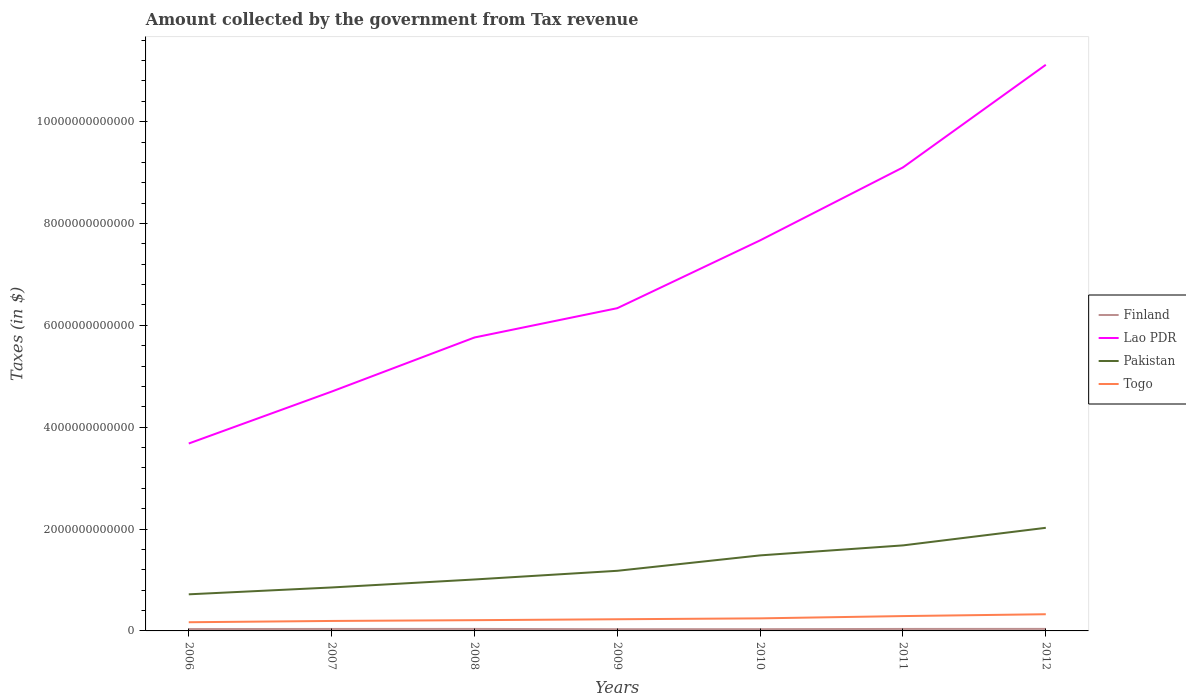Is the number of lines equal to the number of legend labels?
Your answer should be compact. Yes. Across all years, what is the maximum amount collected by the government from tax revenue in Finland?
Provide a short and direct response. 3.38e+1. In which year was the amount collected by the government from tax revenue in Pakistan maximum?
Give a very brief answer. 2006. What is the total amount collected by the government from tax revenue in Finland in the graph?
Ensure brevity in your answer.  -5.21e+09. What is the difference between the highest and the second highest amount collected by the government from tax revenue in Togo?
Offer a terse response. 1.57e+11. What is the difference between the highest and the lowest amount collected by the government from tax revenue in Finland?
Your answer should be very brief. 4. What is the difference between two consecutive major ticks on the Y-axis?
Your answer should be compact. 2.00e+12. Does the graph contain any zero values?
Provide a short and direct response. No. Does the graph contain grids?
Your response must be concise. No. How many legend labels are there?
Offer a terse response. 4. How are the legend labels stacked?
Your answer should be very brief. Vertical. What is the title of the graph?
Offer a terse response. Amount collected by the government from Tax revenue. Does "Ireland" appear as one of the legend labels in the graph?
Your answer should be compact. No. What is the label or title of the X-axis?
Provide a short and direct response. Years. What is the label or title of the Y-axis?
Your answer should be compact. Taxes (in $). What is the Taxes (in $) of Finland in 2006?
Provide a succinct answer. 3.66e+1. What is the Taxes (in $) of Lao PDR in 2006?
Give a very brief answer. 3.68e+12. What is the Taxes (in $) of Pakistan in 2006?
Provide a short and direct response. 7.19e+11. What is the Taxes (in $) in Togo in 2006?
Give a very brief answer. 1.71e+11. What is the Taxes (in $) in Finland in 2007?
Keep it short and to the point. 3.90e+1. What is the Taxes (in $) in Lao PDR in 2007?
Your response must be concise. 4.70e+12. What is the Taxes (in $) of Pakistan in 2007?
Offer a very short reply. 8.53e+11. What is the Taxes (in $) in Togo in 2007?
Keep it short and to the point. 1.96e+11. What is the Taxes (in $) in Finland in 2008?
Provide a short and direct response. 3.94e+1. What is the Taxes (in $) in Lao PDR in 2008?
Ensure brevity in your answer.  5.76e+12. What is the Taxes (in $) in Pakistan in 2008?
Your answer should be very brief. 1.01e+12. What is the Taxes (in $) in Togo in 2008?
Provide a short and direct response. 2.11e+11. What is the Taxes (in $) in Finland in 2009?
Your answer should be very brief. 3.38e+1. What is the Taxes (in $) of Lao PDR in 2009?
Provide a succinct answer. 6.34e+12. What is the Taxes (in $) in Pakistan in 2009?
Give a very brief answer. 1.18e+12. What is the Taxes (in $) in Togo in 2009?
Provide a short and direct response. 2.29e+11. What is the Taxes (in $) in Finland in 2010?
Offer a very short reply. 3.44e+1. What is the Taxes (in $) of Lao PDR in 2010?
Your answer should be very brief. 7.67e+12. What is the Taxes (in $) in Pakistan in 2010?
Your answer should be very brief. 1.48e+12. What is the Taxes (in $) in Togo in 2010?
Keep it short and to the point. 2.47e+11. What is the Taxes (in $) in Finland in 2011?
Offer a terse response. 3.90e+1. What is the Taxes (in $) in Lao PDR in 2011?
Your answer should be very brief. 9.10e+12. What is the Taxes (in $) of Pakistan in 2011?
Offer a terse response. 1.68e+12. What is the Taxes (in $) in Togo in 2011?
Provide a succinct answer. 2.91e+11. What is the Taxes (in $) of Finland in 2012?
Provide a succinct answer. 3.98e+1. What is the Taxes (in $) of Lao PDR in 2012?
Your answer should be very brief. 1.11e+13. What is the Taxes (in $) in Pakistan in 2012?
Provide a succinct answer. 2.02e+12. What is the Taxes (in $) in Togo in 2012?
Your response must be concise. 3.28e+11. Across all years, what is the maximum Taxes (in $) in Finland?
Your response must be concise. 3.98e+1. Across all years, what is the maximum Taxes (in $) of Lao PDR?
Offer a very short reply. 1.11e+13. Across all years, what is the maximum Taxes (in $) in Pakistan?
Give a very brief answer. 2.02e+12. Across all years, what is the maximum Taxes (in $) in Togo?
Your answer should be compact. 3.28e+11. Across all years, what is the minimum Taxes (in $) in Finland?
Provide a succinct answer. 3.38e+1. Across all years, what is the minimum Taxes (in $) in Lao PDR?
Your answer should be very brief. 3.68e+12. Across all years, what is the minimum Taxes (in $) of Pakistan?
Your answer should be very brief. 7.19e+11. Across all years, what is the minimum Taxes (in $) in Togo?
Keep it short and to the point. 1.71e+11. What is the total Taxes (in $) of Finland in the graph?
Provide a short and direct response. 2.62e+11. What is the total Taxes (in $) in Lao PDR in the graph?
Keep it short and to the point. 4.84e+13. What is the total Taxes (in $) in Pakistan in the graph?
Your answer should be very brief. 8.95e+12. What is the total Taxes (in $) of Togo in the graph?
Give a very brief answer. 1.67e+12. What is the difference between the Taxes (in $) of Finland in 2006 and that in 2007?
Offer a very short reply. -2.32e+09. What is the difference between the Taxes (in $) of Lao PDR in 2006 and that in 2007?
Make the answer very short. -1.02e+12. What is the difference between the Taxes (in $) in Pakistan in 2006 and that in 2007?
Your response must be concise. -1.35e+11. What is the difference between the Taxes (in $) in Togo in 2006 and that in 2007?
Give a very brief answer. -2.53e+1. What is the difference between the Taxes (in $) in Finland in 2006 and that in 2008?
Your answer should be compact. -2.74e+09. What is the difference between the Taxes (in $) in Lao PDR in 2006 and that in 2008?
Make the answer very short. -2.08e+12. What is the difference between the Taxes (in $) of Pakistan in 2006 and that in 2008?
Your response must be concise. -2.91e+11. What is the difference between the Taxes (in $) in Togo in 2006 and that in 2008?
Offer a very short reply. -4.06e+1. What is the difference between the Taxes (in $) of Finland in 2006 and that in 2009?
Offer a terse response. 2.81e+09. What is the difference between the Taxes (in $) in Lao PDR in 2006 and that in 2009?
Your answer should be compact. -2.66e+12. What is the difference between the Taxes (in $) of Pakistan in 2006 and that in 2009?
Offer a terse response. -4.62e+11. What is the difference between the Taxes (in $) of Togo in 2006 and that in 2009?
Offer a very short reply. -5.85e+1. What is the difference between the Taxes (in $) in Finland in 2006 and that in 2010?
Provide a succinct answer. 2.19e+09. What is the difference between the Taxes (in $) of Lao PDR in 2006 and that in 2010?
Your response must be concise. -3.99e+12. What is the difference between the Taxes (in $) of Pakistan in 2006 and that in 2010?
Offer a very short reply. -7.64e+11. What is the difference between the Taxes (in $) in Togo in 2006 and that in 2010?
Keep it short and to the point. -7.62e+1. What is the difference between the Taxes (in $) in Finland in 2006 and that in 2011?
Provide a short and direct response. -2.40e+09. What is the difference between the Taxes (in $) of Lao PDR in 2006 and that in 2011?
Your response must be concise. -5.42e+12. What is the difference between the Taxes (in $) in Pakistan in 2006 and that in 2011?
Make the answer very short. -9.61e+11. What is the difference between the Taxes (in $) of Togo in 2006 and that in 2011?
Make the answer very short. -1.21e+11. What is the difference between the Taxes (in $) in Finland in 2006 and that in 2012?
Provide a short and direct response. -3.18e+09. What is the difference between the Taxes (in $) in Lao PDR in 2006 and that in 2012?
Offer a very short reply. -7.44e+12. What is the difference between the Taxes (in $) in Pakistan in 2006 and that in 2012?
Make the answer very short. -1.31e+12. What is the difference between the Taxes (in $) of Togo in 2006 and that in 2012?
Ensure brevity in your answer.  -1.57e+11. What is the difference between the Taxes (in $) of Finland in 2007 and that in 2008?
Your answer should be very brief. -4.18e+08. What is the difference between the Taxes (in $) in Lao PDR in 2007 and that in 2008?
Give a very brief answer. -1.06e+12. What is the difference between the Taxes (in $) in Pakistan in 2007 and that in 2008?
Keep it short and to the point. -1.57e+11. What is the difference between the Taxes (in $) of Togo in 2007 and that in 2008?
Offer a very short reply. -1.53e+1. What is the difference between the Taxes (in $) in Finland in 2007 and that in 2009?
Provide a succinct answer. 5.14e+09. What is the difference between the Taxes (in $) in Lao PDR in 2007 and that in 2009?
Your response must be concise. -1.64e+12. What is the difference between the Taxes (in $) of Pakistan in 2007 and that in 2009?
Ensure brevity in your answer.  -3.27e+11. What is the difference between the Taxes (in $) in Togo in 2007 and that in 2009?
Offer a terse response. -3.32e+1. What is the difference between the Taxes (in $) of Finland in 2007 and that in 2010?
Provide a short and direct response. 4.51e+09. What is the difference between the Taxes (in $) in Lao PDR in 2007 and that in 2010?
Offer a terse response. -2.97e+12. What is the difference between the Taxes (in $) in Pakistan in 2007 and that in 2010?
Ensure brevity in your answer.  -6.30e+11. What is the difference between the Taxes (in $) of Togo in 2007 and that in 2010?
Ensure brevity in your answer.  -5.09e+1. What is the difference between the Taxes (in $) in Finland in 2007 and that in 2011?
Give a very brief answer. -7.90e+07. What is the difference between the Taxes (in $) in Lao PDR in 2007 and that in 2011?
Keep it short and to the point. -4.40e+12. What is the difference between the Taxes (in $) of Pakistan in 2007 and that in 2011?
Give a very brief answer. -8.26e+11. What is the difference between the Taxes (in $) in Togo in 2007 and that in 2011?
Your answer should be very brief. -9.56e+1. What is the difference between the Taxes (in $) in Finland in 2007 and that in 2012?
Offer a terse response. -8.57e+08. What is the difference between the Taxes (in $) in Lao PDR in 2007 and that in 2012?
Provide a succinct answer. -6.42e+12. What is the difference between the Taxes (in $) in Pakistan in 2007 and that in 2012?
Give a very brief answer. -1.17e+12. What is the difference between the Taxes (in $) of Togo in 2007 and that in 2012?
Provide a succinct answer. -1.32e+11. What is the difference between the Taxes (in $) in Finland in 2008 and that in 2009?
Give a very brief answer. 5.55e+09. What is the difference between the Taxes (in $) in Lao PDR in 2008 and that in 2009?
Ensure brevity in your answer.  -5.76e+11. What is the difference between the Taxes (in $) in Pakistan in 2008 and that in 2009?
Your answer should be very brief. -1.71e+11. What is the difference between the Taxes (in $) of Togo in 2008 and that in 2009?
Your answer should be very brief. -1.79e+1. What is the difference between the Taxes (in $) of Finland in 2008 and that in 2010?
Make the answer very short. 4.93e+09. What is the difference between the Taxes (in $) in Lao PDR in 2008 and that in 2010?
Ensure brevity in your answer.  -1.91e+12. What is the difference between the Taxes (in $) of Pakistan in 2008 and that in 2010?
Ensure brevity in your answer.  -4.73e+11. What is the difference between the Taxes (in $) in Togo in 2008 and that in 2010?
Offer a terse response. -3.56e+1. What is the difference between the Taxes (in $) of Finland in 2008 and that in 2011?
Ensure brevity in your answer.  3.39e+08. What is the difference between the Taxes (in $) of Lao PDR in 2008 and that in 2011?
Provide a short and direct response. -3.34e+12. What is the difference between the Taxes (in $) of Pakistan in 2008 and that in 2011?
Offer a very short reply. -6.69e+11. What is the difference between the Taxes (in $) of Togo in 2008 and that in 2011?
Make the answer very short. -8.02e+1. What is the difference between the Taxes (in $) of Finland in 2008 and that in 2012?
Offer a very short reply. -4.39e+08. What is the difference between the Taxes (in $) in Lao PDR in 2008 and that in 2012?
Provide a succinct answer. -5.35e+12. What is the difference between the Taxes (in $) in Pakistan in 2008 and that in 2012?
Your answer should be compact. -1.01e+12. What is the difference between the Taxes (in $) of Togo in 2008 and that in 2012?
Offer a terse response. -1.16e+11. What is the difference between the Taxes (in $) in Finland in 2009 and that in 2010?
Ensure brevity in your answer.  -6.23e+08. What is the difference between the Taxes (in $) of Lao PDR in 2009 and that in 2010?
Give a very brief answer. -1.33e+12. What is the difference between the Taxes (in $) in Pakistan in 2009 and that in 2010?
Give a very brief answer. -3.03e+11. What is the difference between the Taxes (in $) in Togo in 2009 and that in 2010?
Offer a terse response. -1.77e+1. What is the difference between the Taxes (in $) of Finland in 2009 and that in 2011?
Your response must be concise. -5.21e+09. What is the difference between the Taxes (in $) in Lao PDR in 2009 and that in 2011?
Provide a short and direct response. -2.76e+12. What is the difference between the Taxes (in $) in Pakistan in 2009 and that in 2011?
Give a very brief answer. -4.99e+11. What is the difference between the Taxes (in $) in Togo in 2009 and that in 2011?
Keep it short and to the point. -6.24e+1. What is the difference between the Taxes (in $) of Finland in 2009 and that in 2012?
Provide a succinct answer. -5.99e+09. What is the difference between the Taxes (in $) of Lao PDR in 2009 and that in 2012?
Offer a very short reply. -4.78e+12. What is the difference between the Taxes (in $) in Pakistan in 2009 and that in 2012?
Offer a terse response. -8.44e+11. What is the difference between the Taxes (in $) in Togo in 2009 and that in 2012?
Offer a very short reply. -9.86e+1. What is the difference between the Taxes (in $) in Finland in 2010 and that in 2011?
Offer a terse response. -4.59e+09. What is the difference between the Taxes (in $) of Lao PDR in 2010 and that in 2011?
Give a very brief answer. -1.43e+12. What is the difference between the Taxes (in $) of Pakistan in 2010 and that in 2011?
Your answer should be compact. -1.96e+11. What is the difference between the Taxes (in $) in Togo in 2010 and that in 2011?
Give a very brief answer. -4.47e+1. What is the difference between the Taxes (in $) of Finland in 2010 and that in 2012?
Provide a short and direct response. -5.37e+09. What is the difference between the Taxes (in $) in Lao PDR in 2010 and that in 2012?
Keep it short and to the point. -3.45e+12. What is the difference between the Taxes (in $) of Pakistan in 2010 and that in 2012?
Keep it short and to the point. -5.42e+11. What is the difference between the Taxes (in $) in Togo in 2010 and that in 2012?
Ensure brevity in your answer.  -8.09e+1. What is the difference between the Taxes (in $) in Finland in 2011 and that in 2012?
Your response must be concise. -7.78e+08. What is the difference between the Taxes (in $) of Lao PDR in 2011 and that in 2012?
Provide a short and direct response. -2.02e+12. What is the difference between the Taxes (in $) in Pakistan in 2011 and that in 2012?
Offer a terse response. -3.45e+11. What is the difference between the Taxes (in $) in Togo in 2011 and that in 2012?
Ensure brevity in your answer.  -3.63e+1. What is the difference between the Taxes (in $) in Finland in 2006 and the Taxes (in $) in Lao PDR in 2007?
Your answer should be compact. -4.66e+12. What is the difference between the Taxes (in $) in Finland in 2006 and the Taxes (in $) in Pakistan in 2007?
Your answer should be very brief. -8.17e+11. What is the difference between the Taxes (in $) in Finland in 2006 and the Taxes (in $) in Togo in 2007?
Your answer should be compact. -1.59e+11. What is the difference between the Taxes (in $) in Lao PDR in 2006 and the Taxes (in $) in Pakistan in 2007?
Provide a succinct answer. 2.83e+12. What is the difference between the Taxes (in $) in Lao PDR in 2006 and the Taxes (in $) in Togo in 2007?
Make the answer very short. 3.48e+12. What is the difference between the Taxes (in $) in Pakistan in 2006 and the Taxes (in $) in Togo in 2007?
Offer a terse response. 5.23e+11. What is the difference between the Taxes (in $) in Finland in 2006 and the Taxes (in $) in Lao PDR in 2008?
Offer a terse response. -5.72e+12. What is the difference between the Taxes (in $) in Finland in 2006 and the Taxes (in $) in Pakistan in 2008?
Give a very brief answer. -9.73e+11. What is the difference between the Taxes (in $) of Finland in 2006 and the Taxes (in $) of Togo in 2008?
Make the answer very short. -1.75e+11. What is the difference between the Taxes (in $) of Lao PDR in 2006 and the Taxes (in $) of Pakistan in 2008?
Make the answer very short. 2.67e+12. What is the difference between the Taxes (in $) of Lao PDR in 2006 and the Taxes (in $) of Togo in 2008?
Ensure brevity in your answer.  3.47e+12. What is the difference between the Taxes (in $) in Pakistan in 2006 and the Taxes (in $) in Togo in 2008?
Offer a terse response. 5.07e+11. What is the difference between the Taxes (in $) in Finland in 2006 and the Taxes (in $) in Lao PDR in 2009?
Provide a succinct answer. -6.30e+12. What is the difference between the Taxes (in $) of Finland in 2006 and the Taxes (in $) of Pakistan in 2009?
Give a very brief answer. -1.14e+12. What is the difference between the Taxes (in $) of Finland in 2006 and the Taxes (in $) of Togo in 2009?
Make the answer very short. -1.92e+11. What is the difference between the Taxes (in $) of Lao PDR in 2006 and the Taxes (in $) of Pakistan in 2009?
Your answer should be compact. 2.50e+12. What is the difference between the Taxes (in $) in Lao PDR in 2006 and the Taxes (in $) in Togo in 2009?
Make the answer very short. 3.45e+12. What is the difference between the Taxes (in $) in Pakistan in 2006 and the Taxes (in $) in Togo in 2009?
Offer a very short reply. 4.90e+11. What is the difference between the Taxes (in $) in Finland in 2006 and the Taxes (in $) in Lao PDR in 2010?
Give a very brief answer. -7.63e+12. What is the difference between the Taxes (in $) in Finland in 2006 and the Taxes (in $) in Pakistan in 2010?
Keep it short and to the point. -1.45e+12. What is the difference between the Taxes (in $) in Finland in 2006 and the Taxes (in $) in Togo in 2010?
Your response must be concise. -2.10e+11. What is the difference between the Taxes (in $) in Lao PDR in 2006 and the Taxes (in $) in Pakistan in 2010?
Your answer should be compact. 2.20e+12. What is the difference between the Taxes (in $) of Lao PDR in 2006 and the Taxes (in $) of Togo in 2010?
Your answer should be very brief. 3.43e+12. What is the difference between the Taxes (in $) in Pakistan in 2006 and the Taxes (in $) in Togo in 2010?
Offer a terse response. 4.72e+11. What is the difference between the Taxes (in $) in Finland in 2006 and the Taxes (in $) in Lao PDR in 2011?
Ensure brevity in your answer.  -9.06e+12. What is the difference between the Taxes (in $) of Finland in 2006 and the Taxes (in $) of Pakistan in 2011?
Offer a terse response. -1.64e+12. What is the difference between the Taxes (in $) in Finland in 2006 and the Taxes (in $) in Togo in 2011?
Provide a short and direct response. -2.55e+11. What is the difference between the Taxes (in $) of Lao PDR in 2006 and the Taxes (in $) of Pakistan in 2011?
Keep it short and to the point. 2.00e+12. What is the difference between the Taxes (in $) of Lao PDR in 2006 and the Taxes (in $) of Togo in 2011?
Keep it short and to the point. 3.39e+12. What is the difference between the Taxes (in $) in Pakistan in 2006 and the Taxes (in $) in Togo in 2011?
Offer a terse response. 4.27e+11. What is the difference between the Taxes (in $) in Finland in 2006 and the Taxes (in $) in Lao PDR in 2012?
Provide a succinct answer. -1.11e+13. What is the difference between the Taxes (in $) of Finland in 2006 and the Taxes (in $) of Pakistan in 2012?
Your answer should be compact. -1.99e+12. What is the difference between the Taxes (in $) of Finland in 2006 and the Taxes (in $) of Togo in 2012?
Provide a short and direct response. -2.91e+11. What is the difference between the Taxes (in $) of Lao PDR in 2006 and the Taxes (in $) of Pakistan in 2012?
Keep it short and to the point. 1.66e+12. What is the difference between the Taxes (in $) in Lao PDR in 2006 and the Taxes (in $) in Togo in 2012?
Offer a very short reply. 3.35e+12. What is the difference between the Taxes (in $) in Pakistan in 2006 and the Taxes (in $) in Togo in 2012?
Ensure brevity in your answer.  3.91e+11. What is the difference between the Taxes (in $) of Finland in 2007 and the Taxes (in $) of Lao PDR in 2008?
Your answer should be compact. -5.72e+12. What is the difference between the Taxes (in $) of Finland in 2007 and the Taxes (in $) of Pakistan in 2008?
Offer a terse response. -9.71e+11. What is the difference between the Taxes (in $) of Finland in 2007 and the Taxes (in $) of Togo in 2008?
Your answer should be compact. -1.72e+11. What is the difference between the Taxes (in $) in Lao PDR in 2007 and the Taxes (in $) in Pakistan in 2008?
Provide a succinct answer. 3.69e+12. What is the difference between the Taxes (in $) in Lao PDR in 2007 and the Taxes (in $) in Togo in 2008?
Make the answer very short. 4.49e+12. What is the difference between the Taxes (in $) in Pakistan in 2007 and the Taxes (in $) in Togo in 2008?
Give a very brief answer. 6.42e+11. What is the difference between the Taxes (in $) of Finland in 2007 and the Taxes (in $) of Lao PDR in 2009?
Offer a very short reply. -6.30e+12. What is the difference between the Taxes (in $) of Finland in 2007 and the Taxes (in $) of Pakistan in 2009?
Your response must be concise. -1.14e+12. What is the difference between the Taxes (in $) in Finland in 2007 and the Taxes (in $) in Togo in 2009?
Give a very brief answer. -1.90e+11. What is the difference between the Taxes (in $) in Lao PDR in 2007 and the Taxes (in $) in Pakistan in 2009?
Your response must be concise. 3.52e+12. What is the difference between the Taxes (in $) of Lao PDR in 2007 and the Taxes (in $) of Togo in 2009?
Your answer should be very brief. 4.47e+12. What is the difference between the Taxes (in $) of Pakistan in 2007 and the Taxes (in $) of Togo in 2009?
Offer a very short reply. 6.24e+11. What is the difference between the Taxes (in $) of Finland in 2007 and the Taxes (in $) of Lao PDR in 2010?
Provide a succinct answer. -7.63e+12. What is the difference between the Taxes (in $) of Finland in 2007 and the Taxes (in $) of Pakistan in 2010?
Your answer should be compact. -1.44e+12. What is the difference between the Taxes (in $) in Finland in 2007 and the Taxes (in $) in Togo in 2010?
Provide a short and direct response. -2.08e+11. What is the difference between the Taxes (in $) in Lao PDR in 2007 and the Taxes (in $) in Pakistan in 2010?
Provide a short and direct response. 3.22e+12. What is the difference between the Taxes (in $) in Lao PDR in 2007 and the Taxes (in $) in Togo in 2010?
Offer a very short reply. 4.45e+12. What is the difference between the Taxes (in $) in Pakistan in 2007 and the Taxes (in $) in Togo in 2010?
Provide a succinct answer. 6.06e+11. What is the difference between the Taxes (in $) in Finland in 2007 and the Taxes (in $) in Lao PDR in 2011?
Your answer should be very brief. -9.06e+12. What is the difference between the Taxes (in $) in Finland in 2007 and the Taxes (in $) in Pakistan in 2011?
Give a very brief answer. -1.64e+12. What is the difference between the Taxes (in $) in Finland in 2007 and the Taxes (in $) in Togo in 2011?
Offer a terse response. -2.52e+11. What is the difference between the Taxes (in $) in Lao PDR in 2007 and the Taxes (in $) in Pakistan in 2011?
Give a very brief answer. 3.02e+12. What is the difference between the Taxes (in $) in Lao PDR in 2007 and the Taxes (in $) in Togo in 2011?
Make the answer very short. 4.41e+12. What is the difference between the Taxes (in $) of Pakistan in 2007 and the Taxes (in $) of Togo in 2011?
Give a very brief answer. 5.62e+11. What is the difference between the Taxes (in $) of Finland in 2007 and the Taxes (in $) of Lao PDR in 2012?
Offer a very short reply. -1.11e+13. What is the difference between the Taxes (in $) in Finland in 2007 and the Taxes (in $) in Pakistan in 2012?
Give a very brief answer. -1.99e+12. What is the difference between the Taxes (in $) in Finland in 2007 and the Taxes (in $) in Togo in 2012?
Make the answer very short. -2.89e+11. What is the difference between the Taxes (in $) in Lao PDR in 2007 and the Taxes (in $) in Pakistan in 2012?
Your answer should be very brief. 2.67e+12. What is the difference between the Taxes (in $) of Lao PDR in 2007 and the Taxes (in $) of Togo in 2012?
Your answer should be very brief. 4.37e+12. What is the difference between the Taxes (in $) of Pakistan in 2007 and the Taxes (in $) of Togo in 2012?
Make the answer very short. 5.26e+11. What is the difference between the Taxes (in $) of Finland in 2008 and the Taxes (in $) of Lao PDR in 2009?
Offer a very short reply. -6.30e+12. What is the difference between the Taxes (in $) in Finland in 2008 and the Taxes (in $) in Pakistan in 2009?
Your answer should be very brief. -1.14e+12. What is the difference between the Taxes (in $) in Finland in 2008 and the Taxes (in $) in Togo in 2009?
Give a very brief answer. -1.90e+11. What is the difference between the Taxes (in $) in Lao PDR in 2008 and the Taxes (in $) in Pakistan in 2009?
Give a very brief answer. 4.58e+12. What is the difference between the Taxes (in $) in Lao PDR in 2008 and the Taxes (in $) in Togo in 2009?
Give a very brief answer. 5.53e+12. What is the difference between the Taxes (in $) in Pakistan in 2008 and the Taxes (in $) in Togo in 2009?
Your answer should be very brief. 7.81e+11. What is the difference between the Taxes (in $) in Finland in 2008 and the Taxes (in $) in Lao PDR in 2010?
Your answer should be compact. -7.63e+12. What is the difference between the Taxes (in $) in Finland in 2008 and the Taxes (in $) in Pakistan in 2010?
Provide a succinct answer. -1.44e+12. What is the difference between the Taxes (in $) in Finland in 2008 and the Taxes (in $) in Togo in 2010?
Your answer should be very brief. -2.07e+11. What is the difference between the Taxes (in $) in Lao PDR in 2008 and the Taxes (in $) in Pakistan in 2010?
Your response must be concise. 4.28e+12. What is the difference between the Taxes (in $) in Lao PDR in 2008 and the Taxes (in $) in Togo in 2010?
Ensure brevity in your answer.  5.51e+12. What is the difference between the Taxes (in $) of Pakistan in 2008 and the Taxes (in $) of Togo in 2010?
Make the answer very short. 7.63e+11. What is the difference between the Taxes (in $) of Finland in 2008 and the Taxes (in $) of Lao PDR in 2011?
Ensure brevity in your answer.  -9.06e+12. What is the difference between the Taxes (in $) in Finland in 2008 and the Taxes (in $) in Pakistan in 2011?
Make the answer very short. -1.64e+12. What is the difference between the Taxes (in $) in Finland in 2008 and the Taxes (in $) in Togo in 2011?
Make the answer very short. -2.52e+11. What is the difference between the Taxes (in $) of Lao PDR in 2008 and the Taxes (in $) of Pakistan in 2011?
Ensure brevity in your answer.  4.08e+12. What is the difference between the Taxes (in $) in Lao PDR in 2008 and the Taxes (in $) in Togo in 2011?
Provide a short and direct response. 5.47e+12. What is the difference between the Taxes (in $) in Pakistan in 2008 and the Taxes (in $) in Togo in 2011?
Offer a terse response. 7.18e+11. What is the difference between the Taxes (in $) of Finland in 2008 and the Taxes (in $) of Lao PDR in 2012?
Offer a very short reply. -1.11e+13. What is the difference between the Taxes (in $) in Finland in 2008 and the Taxes (in $) in Pakistan in 2012?
Your response must be concise. -1.99e+12. What is the difference between the Taxes (in $) of Finland in 2008 and the Taxes (in $) of Togo in 2012?
Provide a short and direct response. -2.88e+11. What is the difference between the Taxes (in $) of Lao PDR in 2008 and the Taxes (in $) of Pakistan in 2012?
Keep it short and to the point. 3.74e+12. What is the difference between the Taxes (in $) of Lao PDR in 2008 and the Taxes (in $) of Togo in 2012?
Provide a succinct answer. 5.43e+12. What is the difference between the Taxes (in $) in Pakistan in 2008 and the Taxes (in $) in Togo in 2012?
Make the answer very short. 6.82e+11. What is the difference between the Taxes (in $) in Finland in 2009 and the Taxes (in $) in Lao PDR in 2010?
Your answer should be compact. -7.63e+12. What is the difference between the Taxes (in $) of Finland in 2009 and the Taxes (in $) of Pakistan in 2010?
Your response must be concise. -1.45e+12. What is the difference between the Taxes (in $) in Finland in 2009 and the Taxes (in $) in Togo in 2010?
Ensure brevity in your answer.  -2.13e+11. What is the difference between the Taxes (in $) of Lao PDR in 2009 and the Taxes (in $) of Pakistan in 2010?
Provide a short and direct response. 4.85e+12. What is the difference between the Taxes (in $) in Lao PDR in 2009 and the Taxes (in $) in Togo in 2010?
Offer a very short reply. 6.09e+12. What is the difference between the Taxes (in $) of Pakistan in 2009 and the Taxes (in $) of Togo in 2010?
Make the answer very short. 9.34e+11. What is the difference between the Taxes (in $) of Finland in 2009 and the Taxes (in $) of Lao PDR in 2011?
Ensure brevity in your answer.  -9.07e+12. What is the difference between the Taxes (in $) in Finland in 2009 and the Taxes (in $) in Pakistan in 2011?
Ensure brevity in your answer.  -1.65e+12. What is the difference between the Taxes (in $) in Finland in 2009 and the Taxes (in $) in Togo in 2011?
Your answer should be very brief. -2.58e+11. What is the difference between the Taxes (in $) of Lao PDR in 2009 and the Taxes (in $) of Pakistan in 2011?
Make the answer very short. 4.66e+12. What is the difference between the Taxes (in $) of Lao PDR in 2009 and the Taxes (in $) of Togo in 2011?
Your answer should be very brief. 6.05e+12. What is the difference between the Taxes (in $) in Pakistan in 2009 and the Taxes (in $) in Togo in 2011?
Offer a very short reply. 8.89e+11. What is the difference between the Taxes (in $) in Finland in 2009 and the Taxes (in $) in Lao PDR in 2012?
Offer a terse response. -1.11e+13. What is the difference between the Taxes (in $) of Finland in 2009 and the Taxes (in $) of Pakistan in 2012?
Your answer should be very brief. -1.99e+12. What is the difference between the Taxes (in $) in Finland in 2009 and the Taxes (in $) in Togo in 2012?
Provide a short and direct response. -2.94e+11. What is the difference between the Taxes (in $) of Lao PDR in 2009 and the Taxes (in $) of Pakistan in 2012?
Your answer should be very brief. 4.31e+12. What is the difference between the Taxes (in $) in Lao PDR in 2009 and the Taxes (in $) in Togo in 2012?
Keep it short and to the point. 6.01e+12. What is the difference between the Taxes (in $) of Pakistan in 2009 and the Taxes (in $) of Togo in 2012?
Your answer should be very brief. 8.53e+11. What is the difference between the Taxes (in $) of Finland in 2010 and the Taxes (in $) of Lao PDR in 2011?
Provide a short and direct response. -9.07e+12. What is the difference between the Taxes (in $) in Finland in 2010 and the Taxes (in $) in Pakistan in 2011?
Give a very brief answer. -1.64e+12. What is the difference between the Taxes (in $) in Finland in 2010 and the Taxes (in $) in Togo in 2011?
Offer a very short reply. -2.57e+11. What is the difference between the Taxes (in $) of Lao PDR in 2010 and the Taxes (in $) of Pakistan in 2011?
Provide a short and direct response. 5.99e+12. What is the difference between the Taxes (in $) in Lao PDR in 2010 and the Taxes (in $) in Togo in 2011?
Make the answer very short. 7.38e+12. What is the difference between the Taxes (in $) of Pakistan in 2010 and the Taxes (in $) of Togo in 2011?
Your answer should be very brief. 1.19e+12. What is the difference between the Taxes (in $) in Finland in 2010 and the Taxes (in $) in Lao PDR in 2012?
Your response must be concise. -1.11e+13. What is the difference between the Taxes (in $) in Finland in 2010 and the Taxes (in $) in Pakistan in 2012?
Ensure brevity in your answer.  -1.99e+12. What is the difference between the Taxes (in $) in Finland in 2010 and the Taxes (in $) in Togo in 2012?
Give a very brief answer. -2.93e+11. What is the difference between the Taxes (in $) of Lao PDR in 2010 and the Taxes (in $) of Pakistan in 2012?
Offer a very short reply. 5.64e+12. What is the difference between the Taxes (in $) in Lao PDR in 2010 and the Taxes (in $) in Togo in 2012?
Provide a short and direct response. 7.34e+12. What is the difference between the Taxes (in $) of Pakistan in 2010 and the Taxes (in $) of Togo in 2012?
Your answer should be very brief. 1.16e+12. What is the difference between the Taxes (in $) in Finland in 2011 and the Taxes (in $) in Lao PDR in 2012?
Give a very brief answer. -1.11e+13. What is the difference between the Taxes (in $) in Finland in 2011 and the Taxes (in $) in Pakistan in 2012?
Keep it short and to the point. -1.99e+12. What is the difference between the Taxes (in $) in Finland in 2011 and the Taxes (in $) in Togo in 2012?
Give a very brief answer. -2.89e+11. What is the difference between the Taxes (in $) in Lao PDR in 2011 and the Taxes (in $) in Pakistan in 2012?
Your response must be concise. 7.08e+12. What is the difference between the Taxes (in $) in Lao PDR in 2011 and the Taxes (in $) in Togo in 2012?
Your answer should be compact. 8.77e+12. What is the difference between the Taxes (in $) in Pakistan in 2011 and the Taxes (in $) in Togo in 2012?
Your response must be concise. 1.35e+12. What is the average Taxes (in $) of Finland per year?
Give a very brief answer. 3.74e+1. What is the average Taxes (in $) in Lao PDR per year?
Keep it short and to the point. 6.91e+12. What is the average Taxes (in $) in Pakistan per year?
Your response must be concise. 1.28e+12. What is the average Taxes (in $) of Togo per year?
Your response must be concise. 2.39e+11. In the year 2006, what is the difference between the Taxes (in $) of Finland and Taxes (in $) of Lao PDR?
Offer a terse response. -3.64e+12. In the year 2006, what is the difference between the Taxes (in $) of Finland and Taxes (in $) of Pakistan?
Your response must be concise. -6.82e+11. In the year 2006, what is the difference between the Taxes (in $) in Finland and Taxes (in $) in Togo?
Your response must be concise. -1.34e+11. In the year 2006, what is the difference between the Taxes (in $) of Lao PDR and Taxes (in $) of Pakistan?
Your answer should be very brief. 2.96e+12. In the year 2006, what is the difference between the Taxes (in $) in Lao PDR and Taxes (in $) in Togo?
Offer a terse response. 3.51e+12. In the year 2006, what is the difference between the Taxes (in $) in Pakistan and Taxes (in $) in Togo?
Your answer should be compact. 5.48e+11. In the year 2007, what is the difference between the Taxes (in $) of Finland and Taxes (in $) of Lao PDR?
Provide a succinct answer. -4.66e+12. In the year 2007, what is the difference between the Taxes (in $) in Finland and Taxes (in $) in Pakistan?
Provide a short and direct response. -8.14e+11. In the year 2007, what is the difference between the Taxes (in $) of Finland and Taxes (in $) of Togo?
Offer a very short reply. -1.57e+11. In the year 2007, what is the difference between the Taxes (in $) of Lao PDR and Taxes (in $) of Pakistan?
Give a very brief answer. 3.85e+12. In the year 2007, what is the difference between the Taxes (in $) of Lao PDR and Taxes (in $) of Togo?
Provide a short and direct response. 4.50e+12. In the year 2007, what is the difference between the Taxes (in $) of Pakistan and Taxes (in $) of Togo?
Ensure brevity in your answer.  6.57e+11. In the year 2008, what is the difference between the Taxes (in $) in Finland and Taxes (in $) in Lao PDR?
Offer a terse response. -5.72e+12. In the year 2008, what is the difference between the Taxes (in $) of Finland and Taxes (in $) of Pakistan?
Your response must be concise. -9.71e+11. In the year 2008, what is the difference between the Taxes (in $) of Finland and Taxes (in $) of Togo?
Give a very brief answer. -1.72e+11. In the year 2008, what is the difference between the Taxes (in $) of Lao PDR and Taxes (in $) of Pakistan?
Provide a short and direct response. 4.75e+12. In the year 2008, what is the difference between the Taxes (in $) in Lao PDR and Taxes (in $) in Togo?
Offer a terse response. 5.55e+12. In the year 2008, what is the difference between the Taxes (in $) in Pakistan and Taxes (in $) in Togo?
Keep it short and to the point. 7.99e+11. In the year 2009, what is the difference between the Taxes (in $) in Finland and Taxes (in $) in Lao PDR?
Provide a succinct answer. -6.30e+12. In the year 2009, what is the difference between the Taxes (in $) of Finland and Taxes (in $) of Pakistan?
Keep it short and to the point. -1.15e+12. In the year 2009, what is the difference between the Taxes (in $) in Finland and Taxes (in $) in Togo?
Offer a very short reply. -1.95e+11. In the year 2009, what is the difference between the Taxes (in $) of Lao PDR and Taxes (in $) of Pakistan?
Your response must be concise. 5.16e+12. In the year 2009, what is the difference between the Taxes (in $) in Lao PDR and Taxes (in $) in Togo?
Your response must be concise. 6.11e+12. In the year 2009, what is the difference between the Taxes (in $) of Pakistan and Taxes (in $) of Togo?
Your response must be concise. 9.51e+11. In the year 2010, what is the difference between the Taxes (in $) of Finland and Taxes (in $) of Lao PDR?
Ensure brevity in your answer.  -7.63e+12. In the year 2010, what is the difference between the Taxes (in $) in Finland and Taxes (in $) in Pakistan?
Give a very brief answer. -1.45e+12. In the year 2010, what is the difference between the Taxes (in $) in Finland and Taxes (in $) in Togo?
Make the answer very short. -2.12e+11. In the year 2010, what is the difference between the Taxes (in $) of Lao PDR and Taxes (in $) of Pakistan?
Your response must be concise. 6.19e+12. In the year 2010, what is the difference between the Taxes (in $) of Lao PDR and Taxes (in $) of Togo?
Your answer should be very brief. 7.42e+12. In the year 2010, what is the difference between the Taxes (in $) of Pakistan and Taxes (in $) of Togo?
Your answer should be very brief. 1.24e+12. In the year 2011, what is the difference between the Taxes (in $) of Finland and Taxes (in $) of Lao PDR?
Your answer should be compact. -9.06e+12. In the year 2011, what is the difference between the Taxes (in $) in Finland and Taxes (in $) in Pakistan?
Offer a terse response. -1.64e+12. In the year 2011, what is the difference between the Taxes (in $) of Finland and Taxes (in $) of Togo?
Ensure brevity in your answer.  -2.52e+11. In the year 2011, what is the difference between the Taxes (in $) in Lao PDR and Taxes (in $) in Pakistan?
Keep it short and to the point. 7.42e+12. In the year 2011, what is the difference between the Taxes (in $) in Lao PDR and Taxes (in $) in Togo?
Offer a very short reply. 8.81e+12. In the year 2011, what is the difference between the Taxes (in $) of Pakistan and Taxes (in $) of Togo?
Offer a very short reply. 1.39e+12. In the year 2012, what is the difference between the Taxes (in $) in Finland and Taxes (in $) in Lao PDR?
Your response must be concise. -1.11e+13. In the year 2012, what is the difference between the Taxes (in $) of Finland and Taxes (in $) of Pakistan?
Give a very brief answer. -1.98e+12. In the year 2012, what is the difference between the Taxes (in $) of Finland and Taxes (in $) of Togo?
Your answer should be compact. -2.88e+11. In the year 2012, what is the difference between the Taxes (in $) in Lao PDR and Taxes (in $) in Pakistan?
Your answer should be compact. 9.09e+12. In the year 2012, what is the difference between the Taxes (in $) of Lao PDR and Taxes (in $) of Togo?
Your answer should be compact. 1.08e+13. In the year 2012, what is the difference between the Taxes (in $) of Pakistan and Taxes (in $) of Togo?
Provide a succinct answer. 1.70e+12. What is the ratio of the Taxes (in $) in Finland in 2006 to that in 2007?
Your answer should be compact. 0.94. What is the ratio of the Taxes (in $) of Lao PDR in 2006 to that in 2007?
Offer a terse response. 0.78. What is the ratio of the Taxes (in $) of Pakistan in 2006 to that in 2007?
Give a very brief answer. 0.84. What is the ratio of the Taxes (in $) in Togo in 2006 to that in 2007?
Ensure brevity in your answer.  0.87. What is the ratio of the Taxes (in $) in Finland in 2006 to that in 2008?
Offer a very short reply. 0.93. What is the ratio of the Taxes (in $) in Lao PDR in 2006 to that in 2008?
Your answer should be compact. 0.64. What is the ratio of the Taxes (in $) of Pakistan in 2006 to that in 2008?
Ensure brevity in your answer.  0.71. What is the ratio of the Taxes (in $) of Togo in 2006 to that in 2008?
Keep it short and to the point. 0.81. What is the ratio of the Taxes (in $) in Finland in 2006 to that in 2009?
Make the answer very short. 1.08. What is the ratio of the Taxes (in $) in Lao PDR in 2006 to that in 2009?
Make the answer very short. 0.58. What is the ratio of the Taxes (in $) in Pakistan in 2006 to that in 2009?
Make the answer very short. 0.61. What is the ratio of the Taxes (in $) of Togo in 2006 to that in 2009?
Give a very brief answer. 0.74. What is the ratio of the Taxes (in $) in Finland in 2006 to that in 2010?
Make the answer very short. 1.06. What is the ratio of the Taxes (in $) in Lao PDR in 2006 to that in 2010?
Offer a terse response. 0.48. What is the ratio of the Taxes (in $) of Pakistan in 2006 to that in 2010?
Your answer should be very brief. 0.48. What is the ratio of the Taxes (in $) of Togo in 2006 to that in 2010?
Give a very brief answer. 0.69. What is the ratio of the Taxes (in $) of Finland in 2006 to that in 2011?
Give a very brief answer. 0.94. What is the ratio of the Taxes (in $) in Lao PDR in 2006 to that in 2011?
Your answer should be very brief. 0.4. What is the ratio of the Taxes (in $) in Pakistan in 2006 to that in 2011?
Your answer should be compact. 0.43. What is the ratio of the Taxes (in $) of Togo in 2006 to that in 2011?
Provide a short and direct response. 0.59. What is the ratio of the Taxes (in $) in Finland in 2006 to that in 2012?
Provide a succinct answer. 0.92. What is the ratio of the Taxes (in $) in Lao PDR in 2006 to that in 2012?
Give a very brief answer. 0.33. What is the ratio of the Taxes (in $) in Pakistan in 2006 to that in 2012?
Make the answer very short. 0.35. What is the ratio of the Taxes (in $) in Togo in 2006 to that in 2012?
Give a very brief answer. 0.52. What is the ratio of the Taxes (in $) of Finland in 2007 to that in 2008?
Your response must be concise. 0.99. What is the ratio of the Taxes (in $) of Lao PDR in 2007 to that in 2008?
Your answer should be compact. 0.82. What is the ratio of the Taxes (in $) of Pakistan in 2007 to that in 2008?
Your answer should be compact. 0.84. What is the ratio of the Taxes (in $) in Togo in 2007 to that in 2008?
Ensure brevity in your answer.  0.93. What is the ratio of the Taxes (in $) in Finland in 2007 to that in 2009?
Offer a very short reply. 1.15. What is the ratio of the Taxes (in $) in Lao PDR in 2007 to that in 2009?
Offer a very short reply. 0.74. What is the ratio of the Taxes (in $) of Pakistan in 2007 to that in 2009?
Provide a short and direct response. 0.72. What is the ratio of the Taxes (in $) of Togo in 2007 to that in 2009?
Your response must be concise. 0.85. What is the ratio of the Taxes (in $) of Finland in 2007 to that in 2010?
Your response must be concise. 1.13. What is the ratio of the Taxes (in $) of Lao PDR in 2007 to that in 2010?
Your answer should be compact. 0.61. What is the ratio of the Taxes (in $) in Pakistan in 2007 to that in 2010?
Your answer should be compact. 0.58. What is the ratio of the Taxes (in $) of Togo in 2007 to that in 2010?
Your answer should be compact. 0.79. What is the ratio of the Taxes (in $) in Lao PDR in 2007 to that in 2011?
Your response must be concise. 0.52. What is the ratio of the Taxes (in $) in Pakistan in 2007 to that in 2011?
Your response must be concise. 0.51. What is the ratio of the Taxes (in $) of Togo in 2007 to that in 2011?
Your response must be concise. 0.67. What is the ratio of the Taxes (in $) in Finland in 2007 to that in 2012?
Make the answer very short. 0.98. What is the ratio of the Taxes (in $) in Lao PDR in 2007 to that in 2012?
Offer a very short reply. 0.42. What is the ratio of the Taxes (in $) in Pakistan in 2007 to that in 2012?
Offer a very short reply. 0.42. What is the ratio of the Taxes (in $) in Togo in 2007 to that in 2012?
Your answer should be compact. 0.6. What is the ratio of the Taxes (in $) in Finland in 2008 to that in 2009?
Ensure brevity in your answer.  1.16. What is the ratio of the Taxes (in $) of Lao PDR in 2008 to that in 2009?
Give a very brief answer. 0.91. What is the ratio of the Taxes (in $) in Pakistan in 2008 to that in 2009?
Offer a terse response. 0.86. What is the ratio of the Taxes (in $) of Togo in 2008 to that in 2009?
Provide a succinct answer. 0.92. What is the ratio of the Taxes (in $) of Finland in 2008 to that in 2010?
Make the answer very short. 1.14. What is the ratio of the Taxes (in $) of Lao PDR in 2008 to that in 2010?
Your answer should be very brief. 0.75. What is the ratio of the Taxes (in $) in Pakistan in 2008 to that in 2010?
Give a very brief answer. 0.68. What is the ratio of the Taxes (in $) of Togo in 2008 to that in 2010?
Keep it short and to the point. 0.86. What is the ratio of the Taxes (in $) in Finland in 2008 to that in 2011?
Your answer should be very brief. 1.01. What is the ratio of the Taxes (in $) of Lao PDR in 2008 to that in 2011?
Keep it short and to the point. 0.63. What is the ratio of the Taxes (in $) of Pakistan in 2008 to that in 2011?
Your response must be concise. 0.6. What is the ratio of the Taxes (in $) of Togo in 2008 to that in 2011?
Provide a succinct answer. 0.72. What is the ratio of the Taxes (in $) of Lao PDR in 2008 to that in 2012?
Offer a very short reply. 0.52. What is the ratio of the Taxes (in $) in Pakistan in 2008 to that in 2012?
Your response must be concise. 0.5. What is the ratio of the Taxes (in $) of Togo in 2008 to that in 2012?
Provide a succinct answer. 0.64. What is the ratio of the Taxes (in $) in Finland in 2009 to that in 2010?
Offer a terse response. 0.98. What is the ratio of the Taxes (in $) of Lao PDR in 2009 to that in 2010?
Your answer should be compact. 0.83. What is the ratio of the Taxes (in $) of Pakistan in 2009 to that in 2010?
Make the answer very short. 0.8. What is the ratio of the Taxes (in $) of Togo in 2009 to that in 2010?
Your response must be concise. 0.93. What is the ratio of the Taxes (in $) in Finland in 2009 to that in 2011?
Your response must be concise. 0.87. What is the ratio of the Taxes (in $) of Lao PDR in 2009 to that in 2011?
Make the answer very short. 0.7. What is the ratio of the Taxes (in $) in Pakistan in 2009 to that in 2011?
Offer a very short reply. 0.7. What is the ratio of the Taxes (in $) of Togo in 2009 to that in 2011?
Offer a very short reply. 0.79. What is the ratio of the Taxes (in $) in Finland in 2009 to that in 2012?
Offer a very short reply. 0.85. What is the ratio of the Taxes (in $) of Lao PDR in 2009 to that in 2012?
Your response must be concise. 0.57. What is the ratio of the Taxes (in $) in Pakistan in 2009 to that in 2012?
Make the answer very short. 0.58. What is the ratio of the Taxes (in $) of Togo in 2009 to that in 2012?
Ensure brevity in your answer.  0.7. What is the ratio of the Taxes (in $) in Finland in 2010 to that in 2011?
Your response must be concise. 0.88. What is the ratio of the Taxes (in $) of Lao PDR in 2010 to that in 2011?
Provide a succinct answer. 0.84. What is the ratio of the Taxes (in $) of Pakistan in 2010 to that in 2011?
Your answer should be very brief. 0.88. What is the ratio of the Taxes (in $) in Togo in 2010 to that in 2011?
Your response must be concise. 0.85. What is the ratio of the Taxes (in $) of Finland in 2010 to that in 2012?
Keep it short and to the point. 0.87. What is the ratio of the Taxes (in $) of Lao PDR in 2010 to that in 2012?
Offer a terse response. 0.69. What is the ratio of the Taxes (in $) of Pakistan in 2010 to that in 2012?
Provide a short and direct response. 0.73. What is the ratio of the Taxes (in $) of Togo in 2010 to that in 2012?
Your answer should be compact. 0.75. What is the ratio of the Taxes (in $) of Finland in 2011 to that in 2012?
Keep it short and to the point. 0.98. What is the ratio of the Taxes (in $) of Lao PDR in 2011 to that in 2012?
Give a very brief answer. 0.82. What is the ratio of the Taxes (in $) in Pakistan in 2011 to that in 2012?
Your response must be concise. 0.83. What is the ratio of the Taxes (in $) in Togo in 2011 to that in 2012?
Give a very brief answer. 0.89. What is the difference between the highest and the second highest Taxes (in $) in Finland?
Your answer should be very brief. 4.39e+08. What is the difference between the highest and the second highest Taxes (in $) in Lao PDR?
Offer a terse response. 2.02e+12. What is the difference between the highest and the second highest Taxes (in $) in Pakistan?
Offer a very short reply. 3.45e+11. What is the difference between the highest and the second highest Taxes (in $) in Togo?
Ensure brevity in your answer.  3.63e+1. What is the difference between the highest and the lowest Taxes (in $) of Finland?
Provide a short and direct response. 5.99e+09. What is the difference between the highest and the lowest Taxes (in $) of Lao PDR?
Provide a short and direct response. 7.44e+12. What is the difference between the highest and the lowest Taxes (in $) of Pakistan?
Your answer should be very brief. 1.31e+12. What is the difference between the highest and the lowest Taxes (in $) of Togo?
Offer a very short reply. 1.57e+11. 